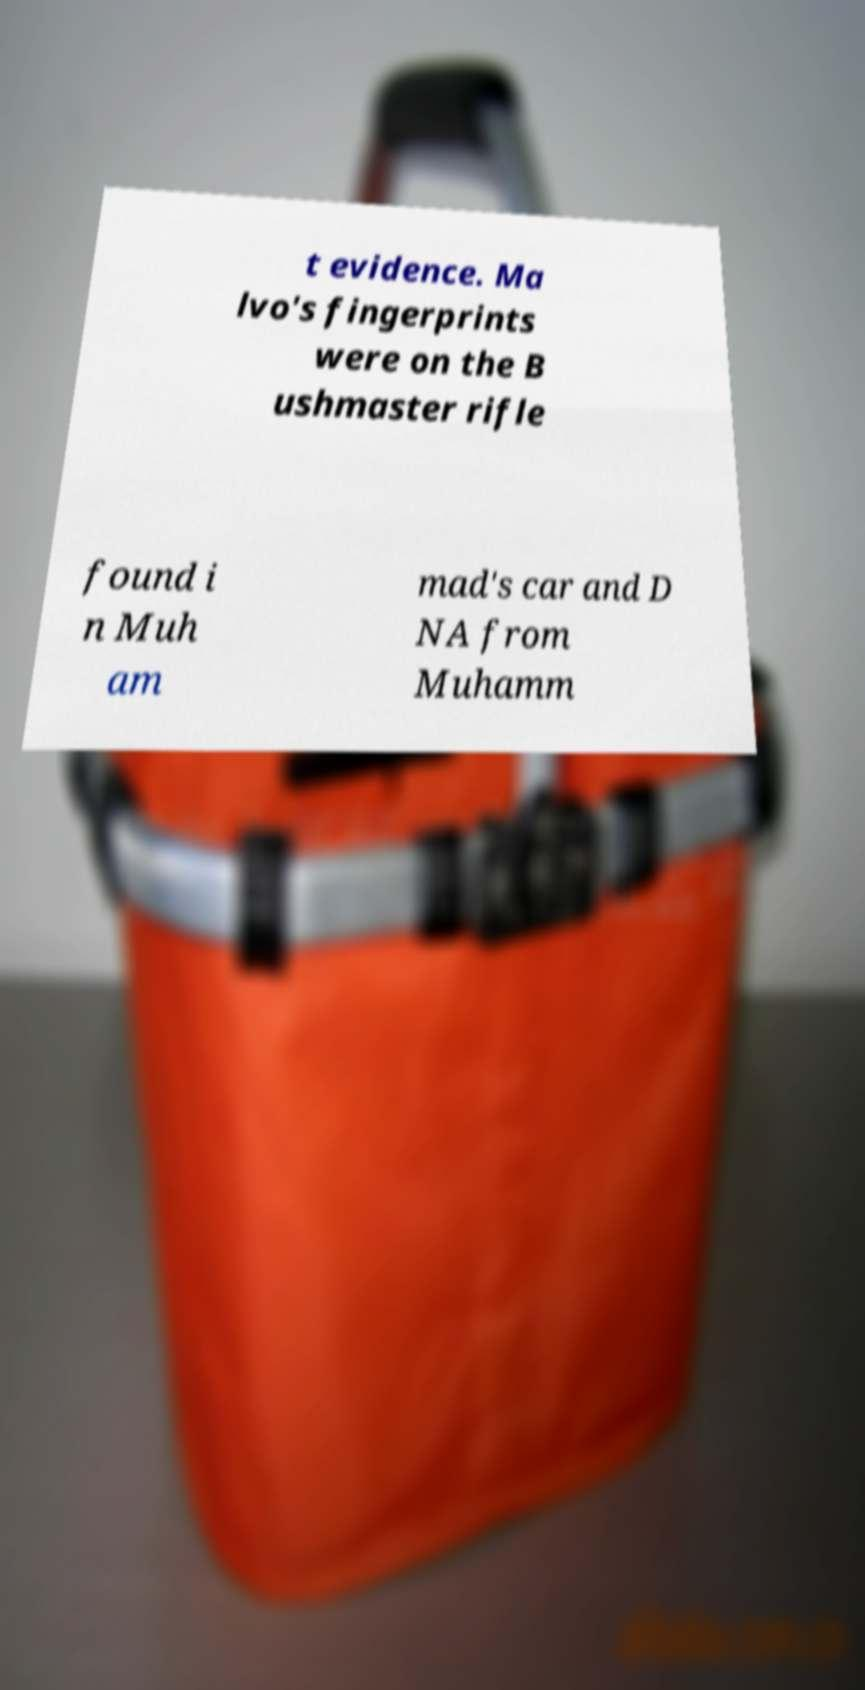Please identify and transcribe the text found in this image. t evidence. Ma lvo's fingerprints were on the B ushmaster rifle found i n Muh am mad's car and D NA from Muhamm 